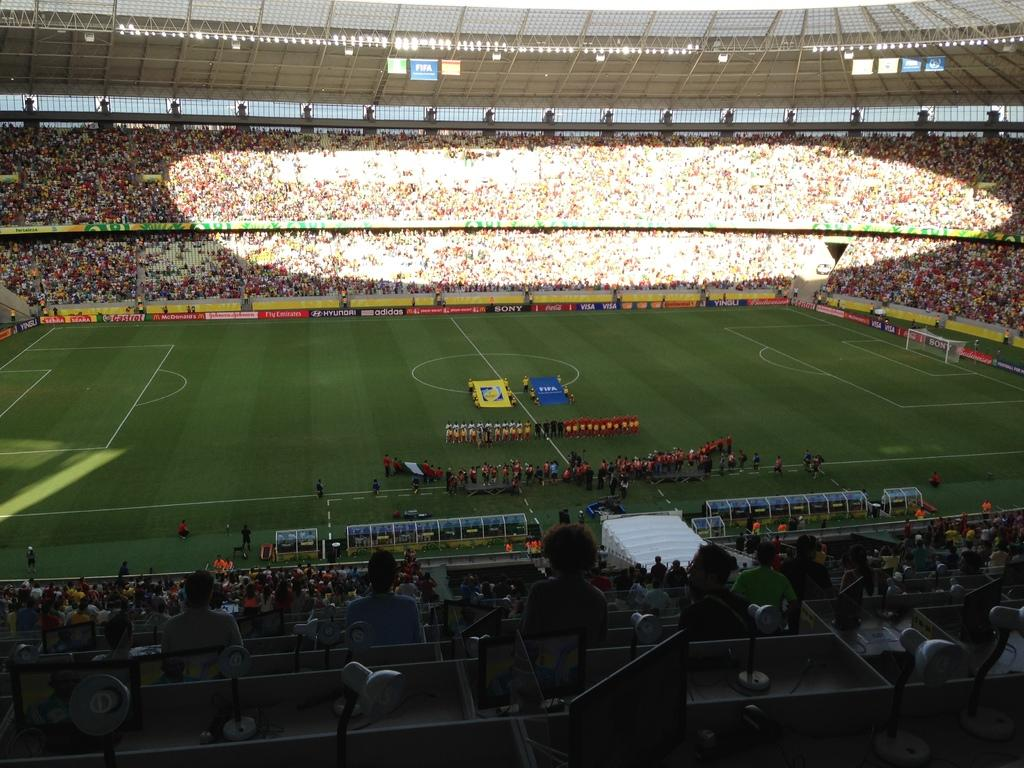How many people are in the image? There is a group of people in the image, but the exact number is not specified. What are some of the people doing in the image? Some people are sitting on chairs, while others are standing on the ground. What can be seen in the background of the image? There are flags, posters, and lights visible in the background. What type of sports equipment is present in the image? There is a football net in the image. Are there any other objects present in the image? Yes, there are some objects in the image, but their specific nature is not mentioned. How many icicles are hanging from the football net in the image? There are no icicles present in the image, as it is not a cold environment where icicles would form. 